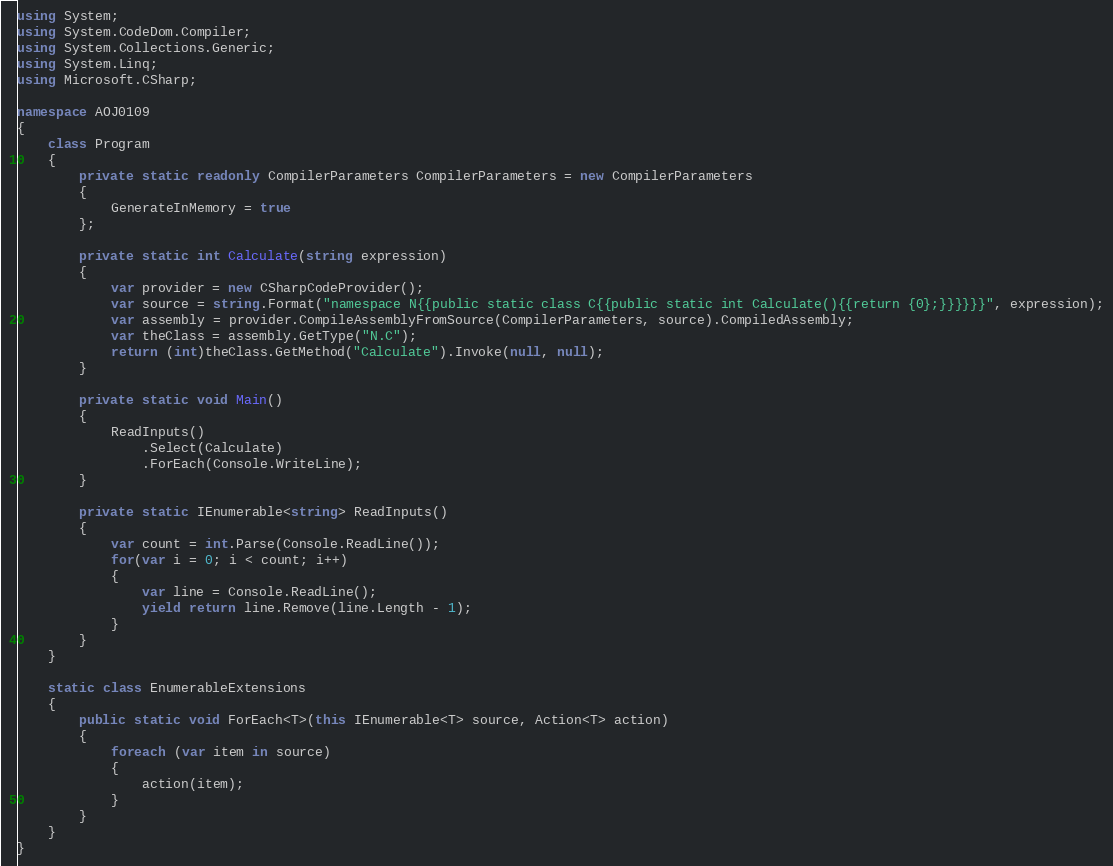Convert code to text. <code><loc_0><loc_0><loc_500><loc_500><_C#_>using System;
using System.CodeDom.Compiler;
using System.Collections.Generic;
using System.Linq;
using Microsoft.CSharp;

namespace AOJ0109
{
    class Program
    {
        private static readonly CompilerParameters CompilerParameters = new CompilerParameters
        {
            GenerateInMemory = true
        };

        private static int Calculate(string expression)
        {
            var provider = new CSharpCodeProvider();
            var source = string.Format("namespace N{{public static class C{{public static int Calculate(){{return {0};}}}}}}", expression);
            var assembly = provider.CompileAssemblyFromSource(CompilerParameters, source).CompiledAssembly;
            var theClass = assembly.GetType("N.C");
            return (int)theClass.GetMethod("Calculate").Invoke(null, null);
        }

        private static void Main()
        {
            ReadInputs()
                .Select(Calculate)
                .ForEach(Console.WriteLine);
        }

        private static IEnumerable<string> ReadInputs()
        {
            var count = int.Parse(Console.ReadLine());
            for(var i = 0; i < count; i++)
            {
                var line = Console.ReadLine();
                yield return line.Remove(line.Length - 1);
            }
        }
    }

    static class EnumerableExtensions
    {
        public static void ForEach<T>(this IEnumerable<T> source, Action<T> action)
        {
            foreach (var item in source)
            {
                action(item);
            }
        }
    }
}</code> 